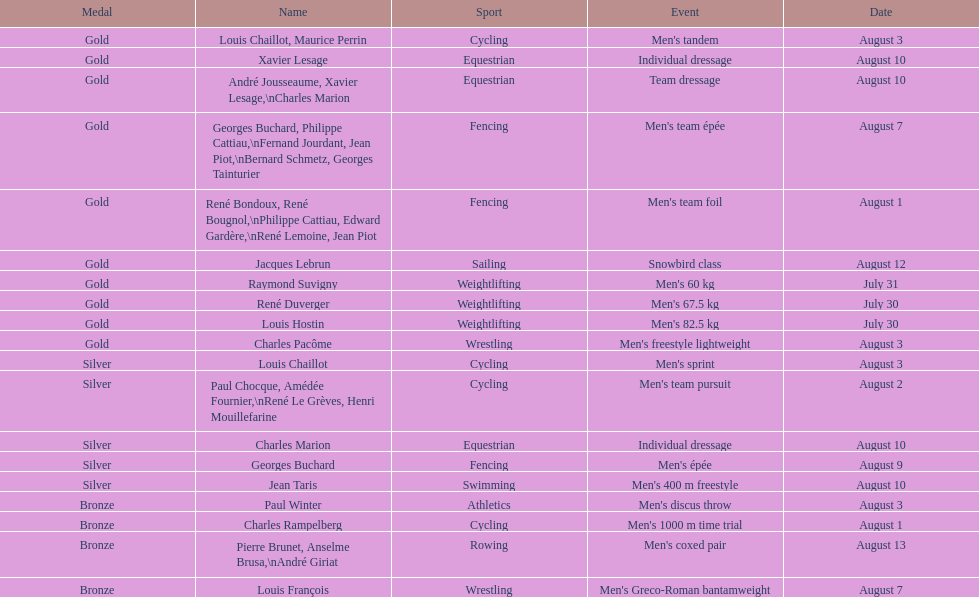Which incident obtained the most accolades? Cycling. 